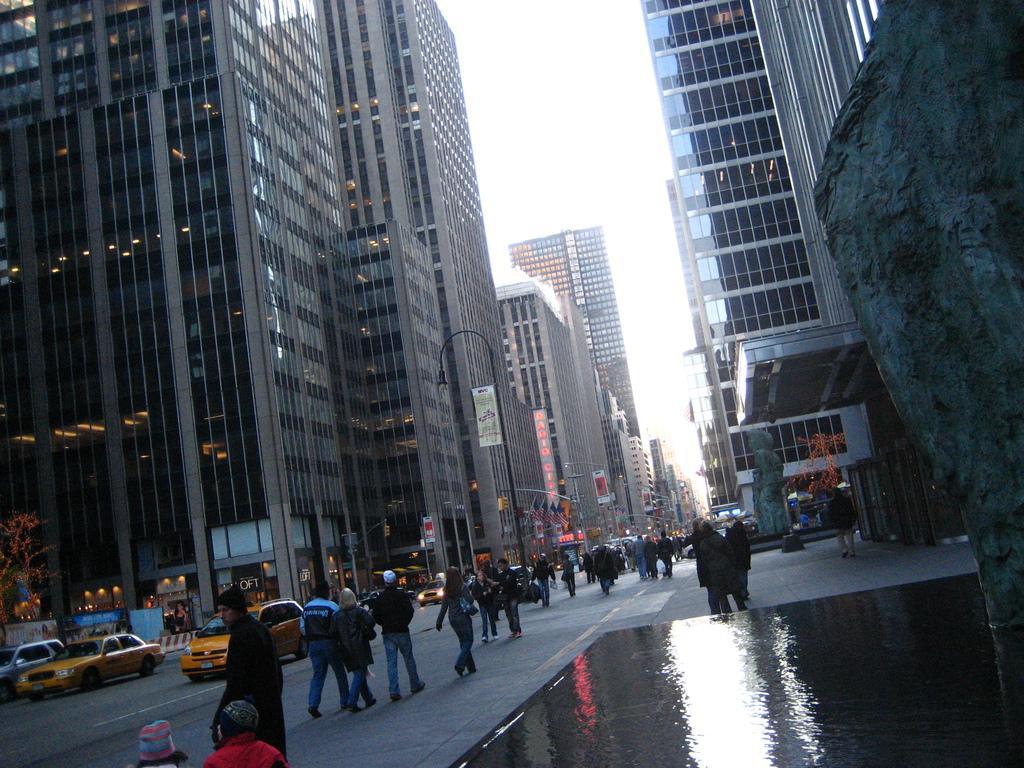In one or two sentences, can you explain what this image depicts? In this picture we can see few people are walking on the road and also few vehicles are on the road, around we can see buildings and trees. 